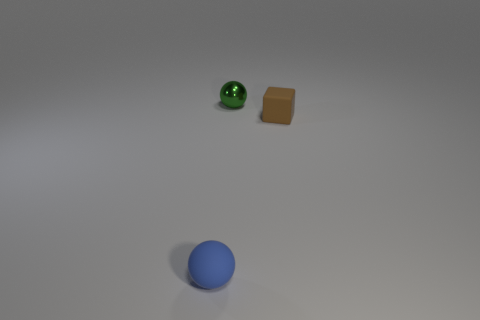There is a blue matte thing that is the same shape as the tiny green thing; what is its size?
Make the answer very short. Small. Is there anything else that has the same shape as the small brown thing?
Make the answer very short. No. There is a brown cube; does it have the same size as the sphere behind the small blue ball?
Your response must be concise. Yes. Is the material of the small ball that is behind the small blue ball the same as the tiny brown block behind the small blue matte sphere?
Offer a very short reply. No. Is the number of brown rubber objects that are in front of the block the same as the number of tiny objects that are right of the tiny blue sphere?
Ensure brevity in your answer.  No. How many shiny things are blocks or blue things?
Provide a succinct answer. 0. Does the tiny object that is in front of the brown cube have the same shape as the object behind the brown object?
Provide a short and direct response. Yes. There is a tiny blue rubber sphere; what number of brown matte objects are behind it?
Give a very brief answer. 1. Are there any small balls made of the same material as the brown block?
Ensure brevity in your answer.  Yes. What material is the cube that is the same size as the rubber sphere?
Make the answer very short. Rubber. 